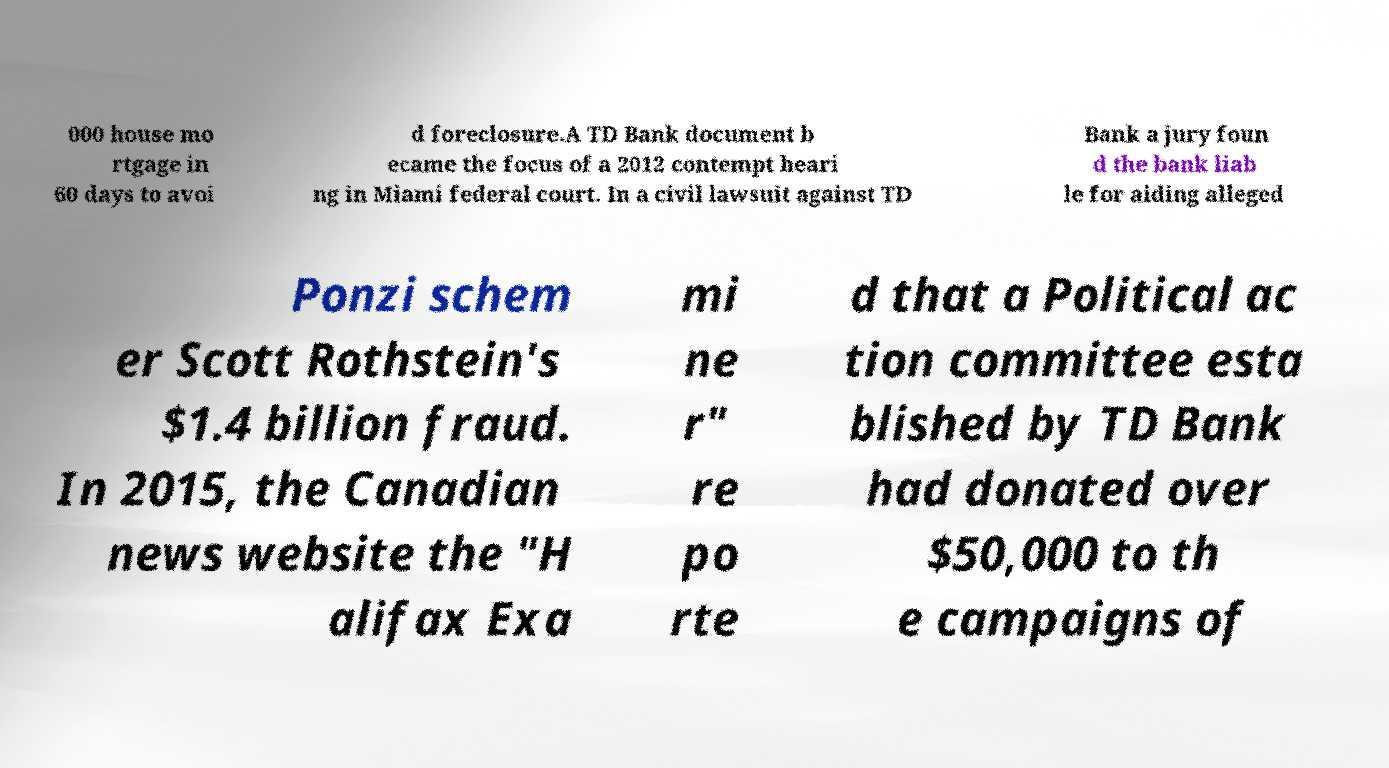There's text embedded in this image that I need extracted. Can you transcribe it verbatim? 000 house mo rtgage in 60 days to avoi d foreclosure.A TD Bank document b ecame the focus of a 2012 contempt heari ng in Miami federal court. In a civil lawsuit against TD Bank a jury foun d the bank liab le for aiding alleged Ponzi schem er Scott Rothstein's $1.4 billion fraud. In 2015, the Canadian news website the "H alifax Exa mi ne r" re po rte d that a Political ac tion committee esta blished by TD Bank had donated over $50,000 to th e campaigns of 